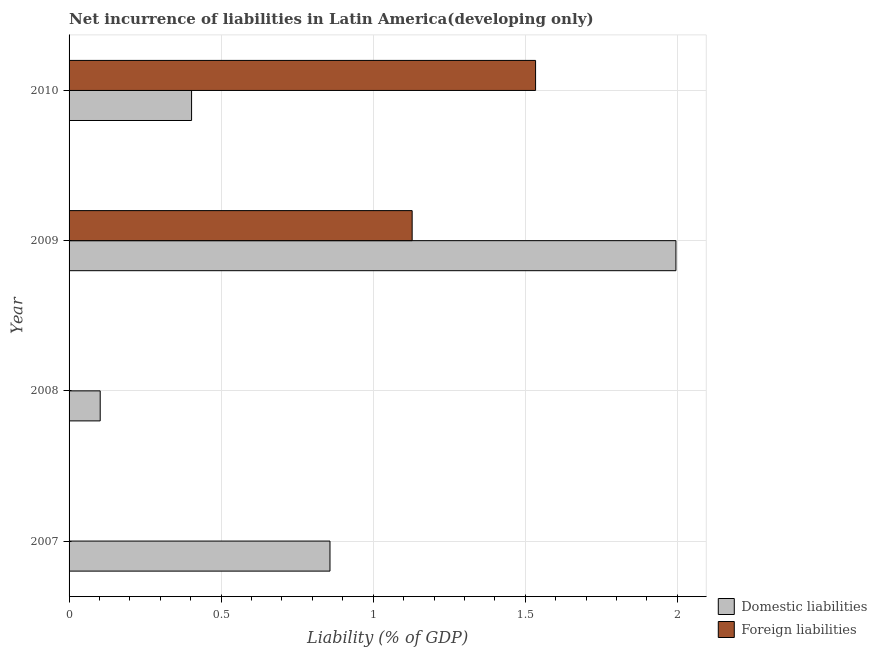Are the number of bars per tick equal to the number of legend labels?
Ensure brevity in your answer.  No. How many bars are there on the 2nd tick from the top?
Provide a succinct answer. 2. How many bars are there on the 4th tick from the bottom?
Offer a terse response. 2. What is the incurrence of foreign liabilities in 2008?
Provide a short and direct response. 0. Across all years, what is the maximum incurrence of domestic liabilities?
Provide a succinct answer. 2. In which year was the incurrence of foreign liabilities maximum?
Your answer should be very brief. 2010. What is the total incurrence of foreign liabilities in the graph?
Your response must be concise. 2.66. What is the difference between the incurrence of domestic liabilities in 2009 and that in 2010?
Ensure brevity in your answer.  1.59. What is the difference between the incurrence of foreign liabilities in 2007 and the incurrence of domestic liabilities in 2009?
Your answer should be very brief. -2. What is the average incurrence of domestic liabilities per year?
Offer a very short reply. 0.84. In the year 2009, what is the difference between the incurrence of domestic liabilities and incurrence of foreign liabilities?
Provide a short and direct response. 0.87. What is the ratio of the incurrence of foreign liabilities in 2009 to that in 2010?
Offer a terse response. 0.73. Is the difference between the incurrence of foreign liabilities in 2009 and 2010 greater than the difference between the incurrence of domestic liabilities in 2009 and 2010?
Make the answer very short. No. What is the difference between the highest and the second highest incurrence of domestic liabilities?
Ensure brevity in your answer.  1.14. What is the difference between the highest and the lowest incurrence of domestic liabilities?
Give a very brief answer. 1.89. In how many years, is the incurrence of foreign liabilities greater than the average incurrence of foreign liabilities taken over all years?
Offer a terse response. 2. How many bars are there?
Provide a succinct answer. 6. Are all the bars in the graph horizontal?
Give a very brief answer. Yes. Does the graph contain grids?
Your answer should be compact. Yes. Where does the legend appear in the graph?
Provide a short and direct response. Bottom right. How are the legend labels stacked?
Your answer should be very brief. Vertical. What is the title of the graph?
Offer a terse response. Net incurrence of liabilities in Latin America(developing only). Does "Overweight" appear as one of the legend labels in the graph?
Give a very brief answer. No. What is the label or title of the X-axis?
Provide a succinct answer. Liability (% of GDP). What is the label or title of the Y-axis?
Your answer should be very brief. Year. What is the Liability (% of GDP) of Domestic liabilities in 2007?
Your answer should be very brief. 0.86. What is the Liability (% of GDP) of Foreign liabilities in 2007?
Provide a short and direct response. 0. What is the Liability (% of GDP) of Domestic liabilities in 2008?
Keep it short and to the point. 0.1. What is the Liability (% of GDP) in Domestic liabilities in 2009?
Your answer should be compact. 2. What is the Liability (% of GDP) of Foreign liabilities in 2009?
Offer a very short reply. 1.13. What is the Liability (% of GDP) in Domestic liabilities in 2010?
Offer a very short reply. 0.4. What is the Liability (% of GDP) of Foreign liabilities in 2010?
Your response must be concise. 1.53. Across all years, what is the maximum Liability (% of GDP) of Domestic liabilities?
Offer a terse response. 2. Across all years, what is the maximum Liability (% of GDP) in Foreign liabilities?
Offer a terse response. 1.53. Across all years, what is the minimum Liability (% of GDP) of Domestic liabilities?
Your answer should be very brief. 0.1. Across all years, what is the minimum Liability (% of GDP) of Foreign liabilities?
Your answer should be very brief. 0. What is the total Liability (% of GDP) of Domestic liabilities in the graph?
Your answer should be compact. 3.36. What is the total Liability (% of GDP) of Foreign liabilities in the graph?
Make the answer very short. 2.66. What is the difference between the Liability (% of GDP) in Domestic liabilities in 2007 and that in 2008?
Make the answer very short. 0.76. What is the difference between the Liability (% of GDP) of Domestic liabilities in 2007 and that in 2009?
Your answer should be compact. -1.14. What is the difference between the Liability (% of GDP) in Domestic liabilities in 2007 and that in 2010?
Your answer should be compact. 0.46. What is the difference between the Liability (% of GDP) of Domestic liabilities in 2008 and that in 2009?
Provide a succinct answer. -1.89. What is the difference between the Liability (% of GDP) in Domestic liabilities in 2008 and that in 2010?
Offer a terse response. -0.3. What is the difference between the Liability (% of GDP) of Domestic liabilities in 2009 and that in 2010?
Offer a terse response. 1.59. What is the difference between the Liability (% of GDP) of Foreign liabilities in 2009 and that in 2010?
Offer a terse response. -0.41. What is the difference between the Liability (% of GDP) in Domestic liabilities in 2007 and the Liability (% of GDP) in Foreign liabilities in 2009?
Offer a terse response. -0.27. What is the difference between the Liability (% of GDP) of Domestic liabilities in 2007 and the Liability (% of GDP) of Foreign liabilities in 2010?
Offer a terse response. -0.68. What is the difference between the Liability (% of GDP) in Domestic liabilities in 2008 and the Liability (% of GDP) in Foreign liabilities in 2009?
Your response must be concise. -1.03. What is the difference between the Liability (% of GDP) of Domestic liabilities in 2008 and the Liability (% of GDP) of Foreign liabilities in 2010?
Offer a very short reply. -1.43. What is the difference between the Liability (% of GDP) in Domestic liabilities in 2009 and the Liability (% of GDP) in Foreign liabilities in 2010?
Keep it short and to the point. 0.46. What is the average Liability (% of GDP) in Domestic liabilities per year?
Offer a very short reply. 0.84. What is the average Liability (% of GDP) in Foreign liabilities per year?
Your answer should be very brief. 0.67. In the year 2009, what is the difference between the Liability (% of GDP) in Domestic liabilities and Liability (% of GDP) in Foreign liabilities?
Your answer should be very brief. 0.87. In the year 2010, what is the difference between the Liability (% of GDP) of Domestic liabilities and Liability (% of GDP) of Foreign liabilities?
Your answer should be very brief. -1.13. What is the ratio of the Liability (% of GDP) in Domestic liabilities in 2007 to that in 2008?
Provide a succinct answer. 8.38. What is the ratio of the Liability (% of GDP) of Domestic liabilities in 2007 to that in 2009?
Give a very brief answer. 0.43. What is the ratio of the Liability (% of GDP) in Domestic liabilities in 2007 to that in 2010?
Keep it short and to the point. 2.13. What is the ratio of the Liability (% of GDP) in Domestic liabilities in 2008 to that in 2009?
Offer a very short reply. 0.05. What is the ratio of the Liability (% of GDP) in Domestic liabilities in 2008 to that in 2010?
Your response must be concise. 0.25. What is the ratio of the Liability (% of GDP) of Domestic liabilities in 2009 to that in 2010?
Keep it short and to the point. 4.95. What is the ratio of the Liability (% of GDP) in Foreign liabilities in 2009 to that in 2010?
Your response must be concise. 0.74. What is the difference between the highest and the second highest Liability (% of GDP) in Domestic liabilities?
Offer a terse response. 1.14. What is the difference between the highest and the lowest Liability (% of GDP) of Domestic liabilities?
Offer a terse response. 1.89. What is the difference between the highest and the lowest Liability (% of GDP) in Foreign liabilities?
Your response must be concise. 1.53. 